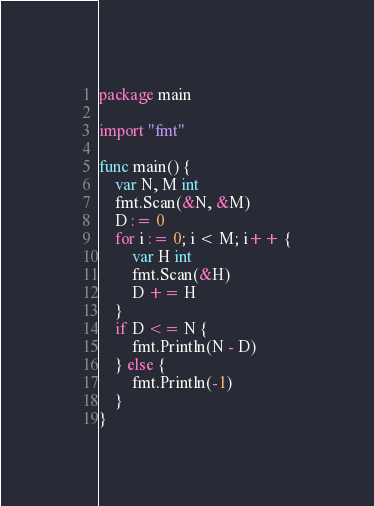<code> <loc_0><loc_0><loc_500><loc_500><_Go_>package main

import "fmt"

func main() {
	var N, M int
	fmt.Scan(&N, &M)
	D := 0
	for i := 0; i < M; i++ {
		var H int
		fmt.Scan(&H)
		D += H
	}
	if D <= N {
		fmt.Println(N - D)
	} else {
		fmt.Println(-1)
	}
}
</code> 